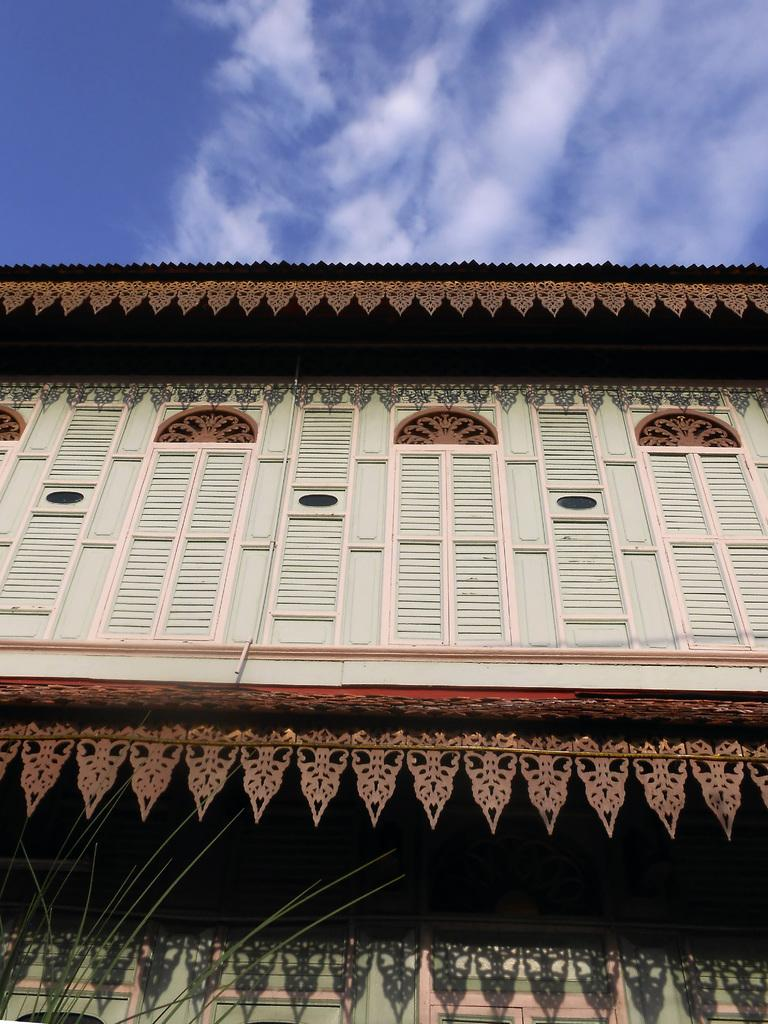What is located on the left side of the image? There is a plant on the left side of the image. What type of structure is visible in the image? There is a building with windows in the image. What can be seen in the background of the image? There are clouds in the blue sky in the background of the image. Where are the toys stored in the image? There are no toys present in the image. What type of beverage is being served in the library in the image? There is no library or beverage mentioned in the image. 